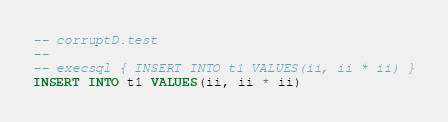Convert code to text. <code><loc_0><loc_0><loc_500><loc_500><_SQL_>-- corruptD.test
-- 
-- execsql { INSERT INTO t1 VALUES(ii, ii * ii) }
INSERT INTO t1 VALUES(ii, ii * ii)
</code> 